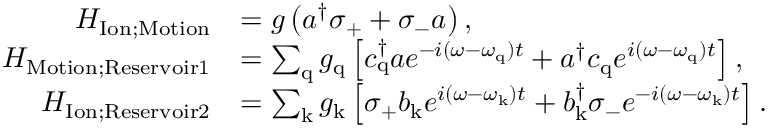Convert formula to latex. <formula><loc_0><loc_0><loc_500><loc_500>\begin{array} { r l } { H _ { I o n ; M o t i o n } } & { = g \left ( a ^ { \dagger } \sigma _ { + } + \sigma _ { - } a \right ) , } \\ { H _ { M o t i o n ; R e s e r v o i r 1 } } & { = \sum _ { q } g _ { q } \left [ c _ { q } ^ { \dagger } a e ^ { - i ( \omega - \omega _ { q } ) t } + a ^ { \dagger } c _ { q } e ^ { i ( \omega - \omega _ { q } ) t } \right ] , } \\ { H _ { I o n ; R e s e r v o i r 2 } } & { = \sum _ { k } g _ { k } \left [ \sigma _ { + } b _ { k } e ^ { i ( \omega - \omega _ { k } ) t } + b _ { k } ^ { \dagger } \sigma _ { - } e ^ { - i ( \omega - \omega _ { k } ) t } \right ] . } \end{array}</formula> 